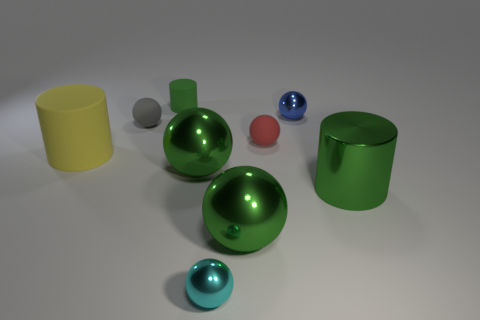Subtract all large cylinders. How many cylinders are left? 1 Add 1 brown matte balls. How many objects exist? 10 Subtract all cyan cubes. How many green cylinders are left? 2 Subtract all yellow cylinders. How many cylinders are left? 2 Subtract 2 spheres. How many spheres are left? 4 Subtract all balls. How many objects are left? 3 Subtract all cyan balls. Subtract all yellow blocks. How many balls are left? 5 Subtract all blue things. Subtract all red rubber objects. How many objects are left? 7 Add 3 tiny gray rubber balls. How many tiny gray rubber balls are left? 4 Add 3 small cyan things. How many small cyan things exist? 4 